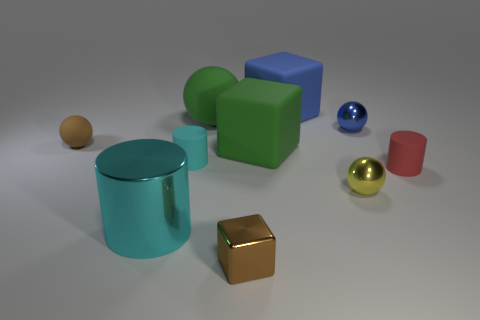Subtract all red cylinders. How many cylinders are left? 2 Subtract all purple blocks. How many cyan cylinders are left? 2 Subtract all blue blocks. How many blocks are left? 2 Subtract all cubes. How many objects are left? 7 Subtract 1 blocks. How many blocks are left? 2 Subtract 0 gray balls. How many objects are left? 10 Subtract all blue cylinders. Subtract all red cubes. How many cylinders are left? 3 Subtract all small cyan balls. Subtract all small blue balls. How many objects are left? 9 Add 4 yellow metal things. How many yellow metal things are left? 5 Add 10 blue metallic cubes. How many blue metallic cubes exist? 10 